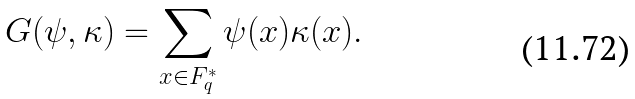<formula> <loc_0><loc_0><loc_500><loc_500>G ( \psi , \kappa ) = \sum _ { x \in F _ { q } ^ { * } } \psi ( x ) \kappa ( x ) .</formula> 